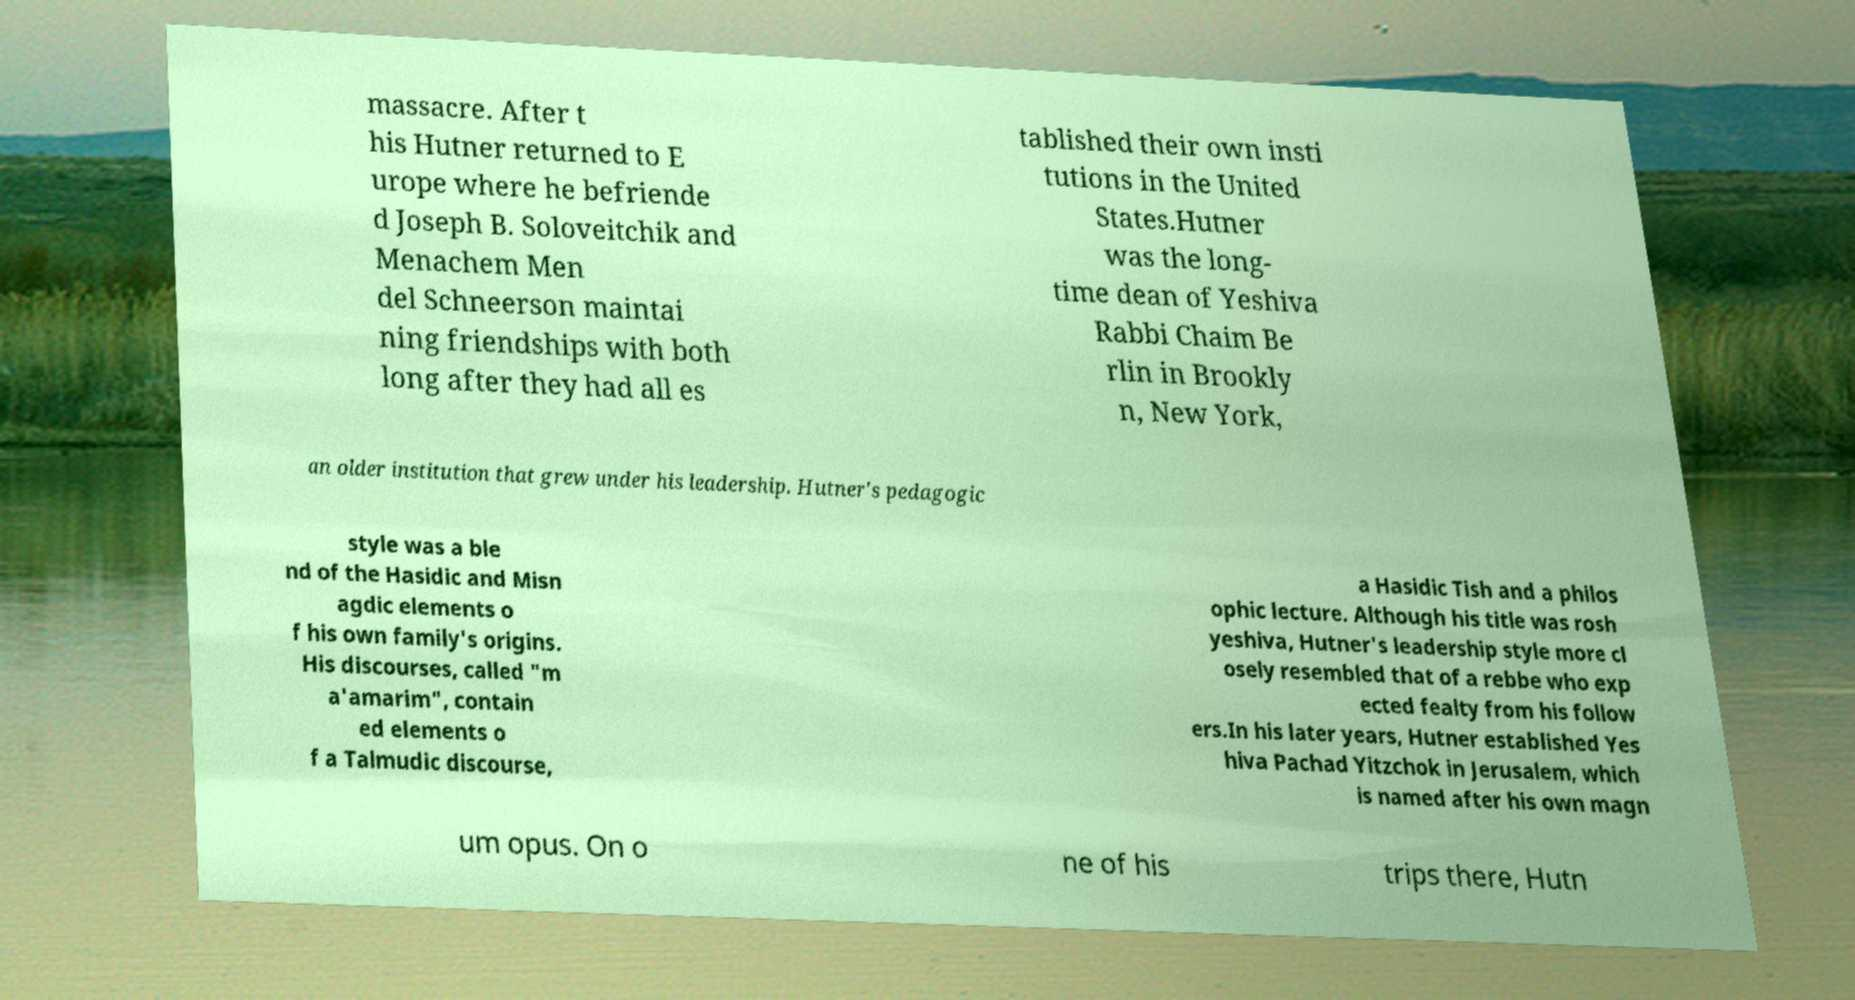Could you assist in decoding the text presented in this image and type it out clearly? massacre. After t his Hutner returned to E urope where he befriende d Joseph B. Soloveitchik and Menachem Men del Schneerson maintai ning friendships with both long after they had all es tablished their own insti tutions in the United States.Hutner was the long- time dean of Yeshiva Rabbi Chaim Be rlin in Brookly n, New York, an older institution that grew under his leadership. Hutner's pedagogic style was a ble nd of the Hasidic and Misn agdic elements o f his own family's origins. His discourses, called "m a'amarim", contain ed elements o f a Talmudic discourse, a Hasidic Tish and a philos ophic lecture. Although his title was rosh yeshiva, Hutner's leadership style more cl osely resembled that of a rebbe who exp ected fealty from his follow ers.In his later years, Hutner established Yes hiva Pachad Yitzchok in Jerusalem, which is named after his own magn um opus. On o ne of his trips there, Hutn 